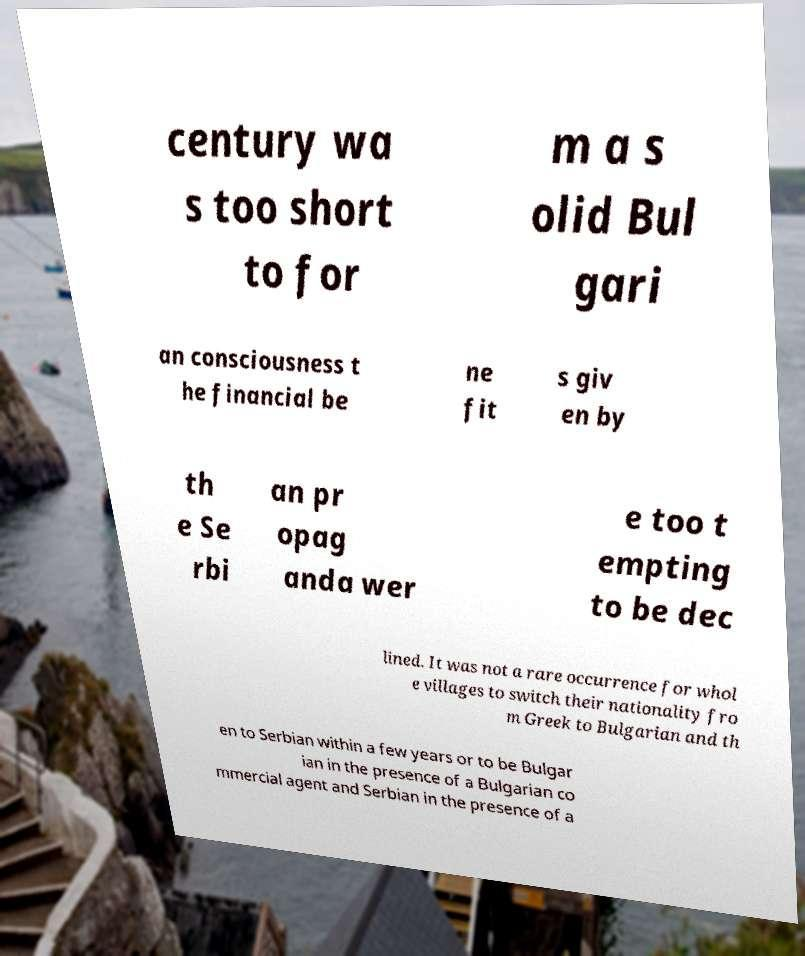Can you accurately transcribe the text from the provided image for me? century wa s too short to for m a s olid Bul gari an consciousness t he financial be ne fit s giv en by th e Se rbi an pr opag anda wer e too t empting to be dec lined. It was not a rare occurrence for whol e villages to switch their nationality fro m Greek to Bulgarian and th en to Serbian within a few years or to be Bulgar ian in the presence of a Bulgarian co mmercial agent and Serbian in the presence of a 